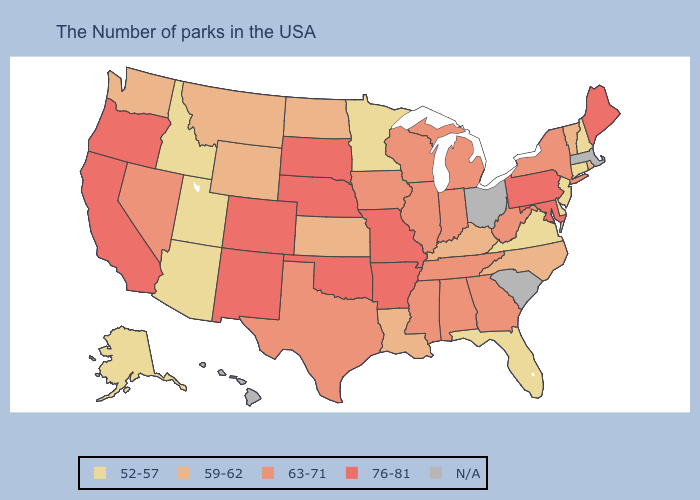What is the highest value in states that border Florida?
Answer briefly. 63-71. Among the states that border Mississippi , does Louisiana have the lowest value?
Be succinct. Yes. What is the value of Minnesota?
Write a very short answer. 52-57. Name the states that have a value in the range 59-62?
Concise answer only. Rhode Island, Vermont, North Carolina, Kentucky, Louisiana, Kansas, North Dakota, Wyoming, Montana, Washington. Name the states that have a value in the range 52-57?
Write a very short answer. New Hampshire, Connecticut, New Jersey, Delaware, Virginia, Florida, Minnesota, Utah, Arizona, Idaho, Alaska. Name the states that have a value in the range 63-71?
Concise answer only. New York, West Virginia, Georgia, Michigan, Indiana, Alabama, Tennessee, Wisconsin, Illinois, Mississippi, Iowa, Texas, Nevada. Name the states that have a value in the range 52-57?
Keep it brief. New Hampshire, Connecticut, New Jersey, Delaware, Virginia, Florida, Minnesota, Utah, Arizona, Idaho, Alaska. What is the highest value in the MidWest ?
Quick response, please. 76-81. Name the states that have a value in the range 63-71?
Be succinct. New York, West Virginia, Georgia, Michigan, Indiana, Alabama, Tennessee, Wisconsin, Illinois, Mississippi, Iowa, Texas, Nevada. Among the states that border Louisiana , which have the highest value?
Be succinct. Arkansas. What is the value of Pennsylvania?
Concise answer only. 76-81. What is the value of Oklahoma?
Keep it brief. 76-81. Does New Mexico have the highest value in the USA?
Quick response, please. Yes. Name the states that have a value in the range N/A?
Give a very brief answer. Massachusetts, South Carolina, Ohio, Hawaii. What is the highest value in states that border Louisiana?
Be succinct. 76-81. 